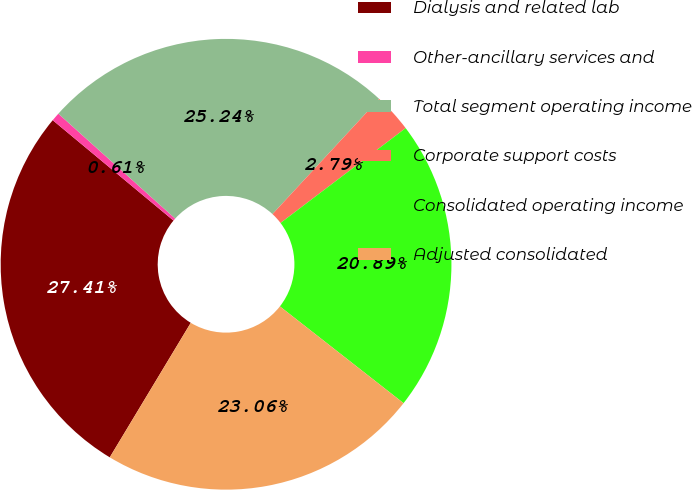Convert chart. <chart><loc_0><loc_0><loc_500><loc_500><pie_chart><fcel>Dialysis and related lab<fcel>Other-ancillary services and<fcel>Total segment operating income<fcel>Corporate support costs<fcel>Consolidated operating income<fcel>Adjusted consolidated<nl><fcel>27.41%<fcel>0.61%<fcel>25.24%<fcel>2.79%<fcel>20.89%<fcel>23.06%<nl></chart> 